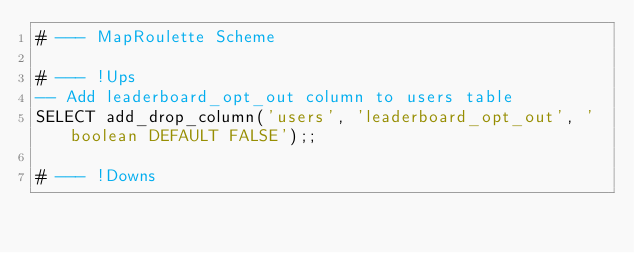<code> <loc_0><loc_0><loc_500><loc_500><_SQL_># --- MapRoulette Scheme

# --- !Ups
-- Add leaderboard_opt_out column to users table
SELECT add_drop_column('users', 'leaderboard_opt_out', 'boolean DEFAULT FALSE');;

# --- !Downs
</code> 